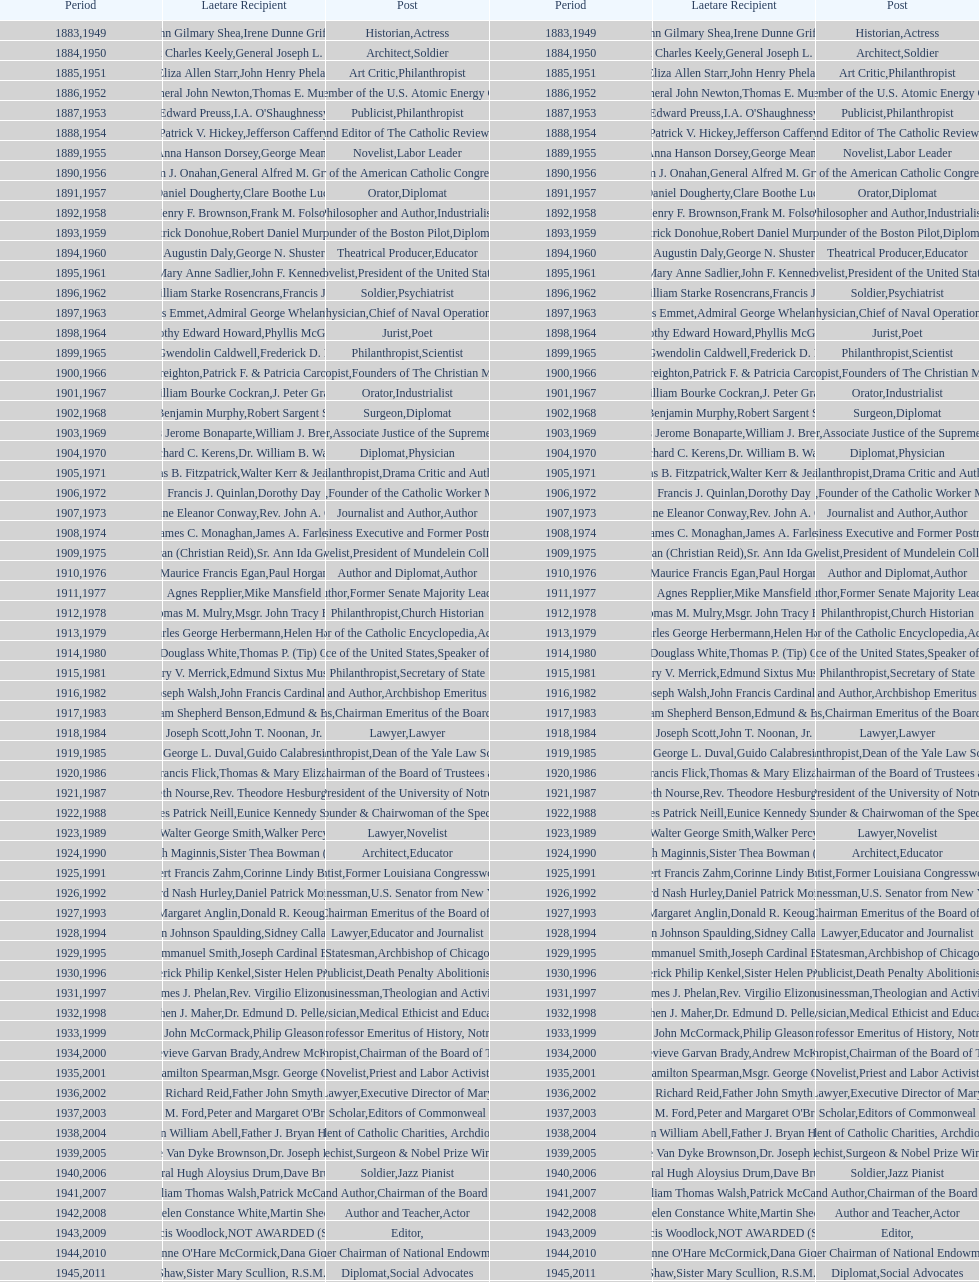What are the total number of times soldier is listed as the position on this chart? 4. 